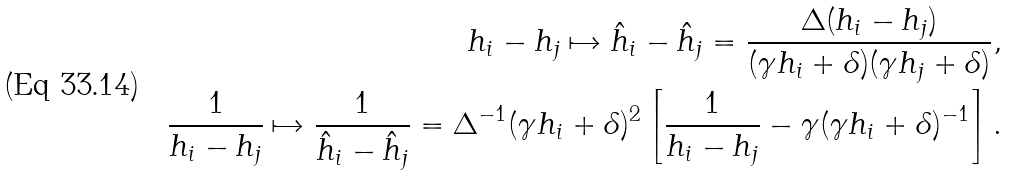<formula> <loc_0><loc_0><loc_500><loc_500>h _ { i } - h _ { j } \mapsto \hat { h } _ { i } - \hat { h } _ { j } = \frac { \Delta ( h _ { i } - h _ { j } ) } { ( \gamma h _ { i } + \delta ) ( \gamma h _ { j } + \delta ) } , \\ \frac { 1 } { h _ { i } - h _ { j } } \mapsto \frac { 1 } { \hat { h } _ { i } - \hat { h } _ { j } } = \Delta ^ { - 1 } ( \gamma h _ { i } + \delta ) ^ { 2 } \left [ \frac { 1 } { h _ { i } - h _ { j } } - \gamma ( \gamma h _ { i } + \delta ) ^ { - 1 } \right ] .</formula> 